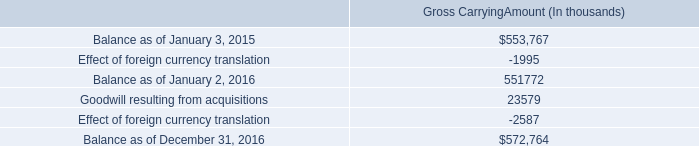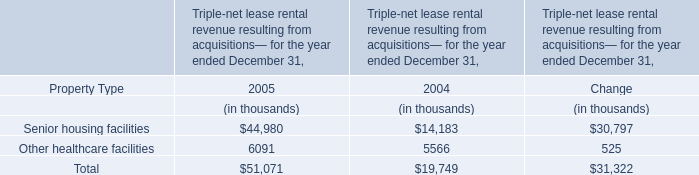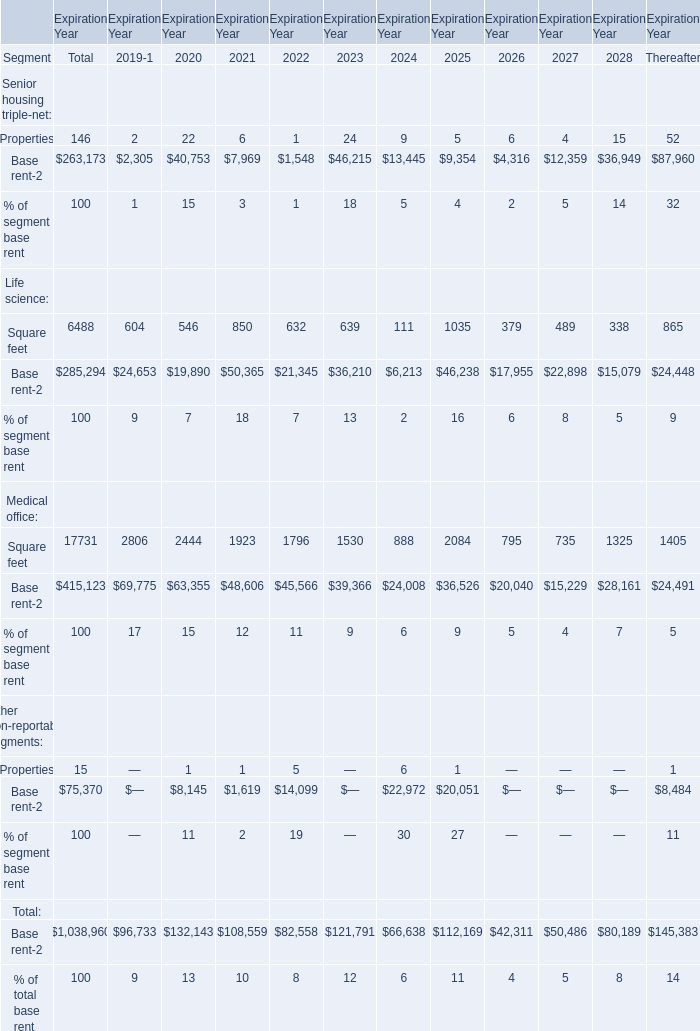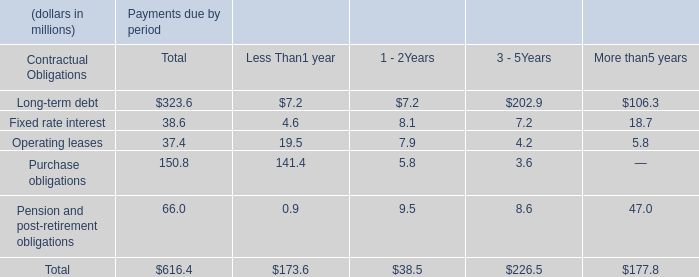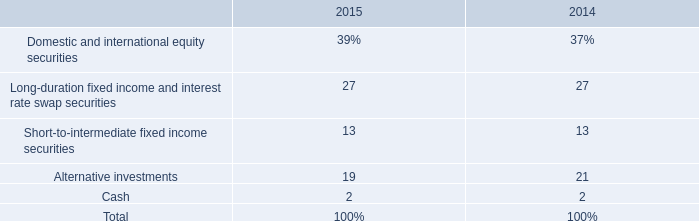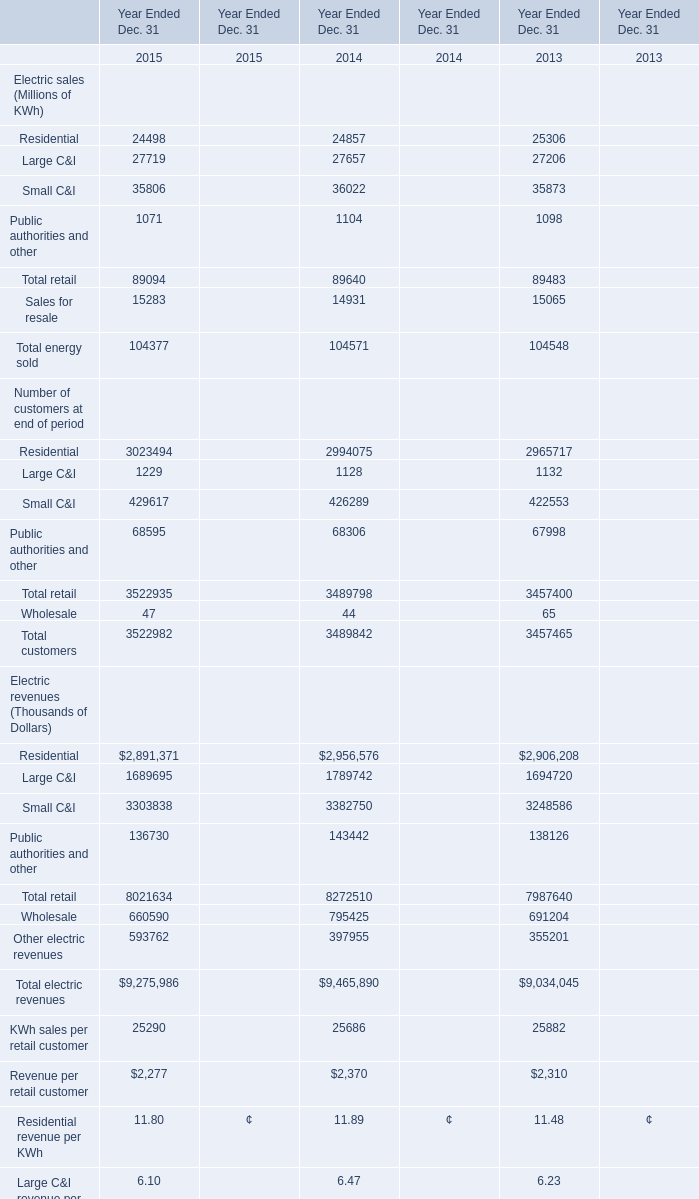What is the average amount of Residential of Year Ended Dec. 31 2014, and Base rent Life science of Expiration Year 2026 ? 
Computations: ((24857.0 + 17955.0) / 2)
Answer: 21406.0. 